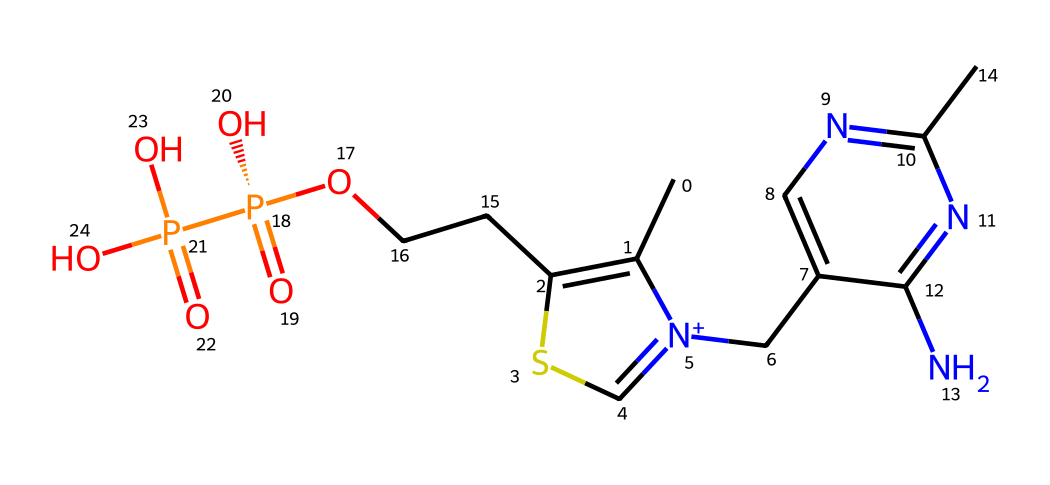What is the primary functional group present in thiamine? The presence of the hydroxyl group (-OH) in the structure indicates that it is the primary functional group. This can be identified by locating the -OH group attached to the carbon chain.
Answer: hydroxyl group How many nitrogen atoms are in thiamine? By examining the SMILES representation, we can count three nitrogen atoms in the structure: two from the pyrimidine ring and one in the thiazole part.
Answer: three What is the molecular mass of thiamine? The molecular mass can be calculated by summing the atomic masses of all the atoms present in the structure based on the SMILES representation. Upon calculation, the molecular weight is approximately 265.25 g/mol.
Answer: 265.25 g/mol Which part of the thiamine structure is involved in forming the coenzyme? The phosphate group (as indicated by the -O[P@](=O)(O) part in the SMILES) is crucial for coenzyme formation. This group allows thiamine to participate in biochemical reactions as a coenzyme.
Answer: phosphate group How many bonds are present between the carbon atoms in thiamine? By analyzing the structure, we observe several carbon-carbon single and double bonds connecting the carbon atoms, specifically six recognizable carbon-carbon bonds can be counted.
Answer: six What type of bond is primarily found between the nitrogen and the carbon in the thiazole ring of thiamine? In the thiazole ring of thiamine, the bond between nitrogen and carbon is primarily characterized as a single covalent bond, which is typical in organonitrogen compounds.
Answer: single covalent bond What specific role does thiamine play in metabolism? Thiamine is essential for the metabolism of carbohydrates, as it acts as a coenzyme in the conversion processes within cells that release energy from glucose.
Answer: carbohydrate metabolism 